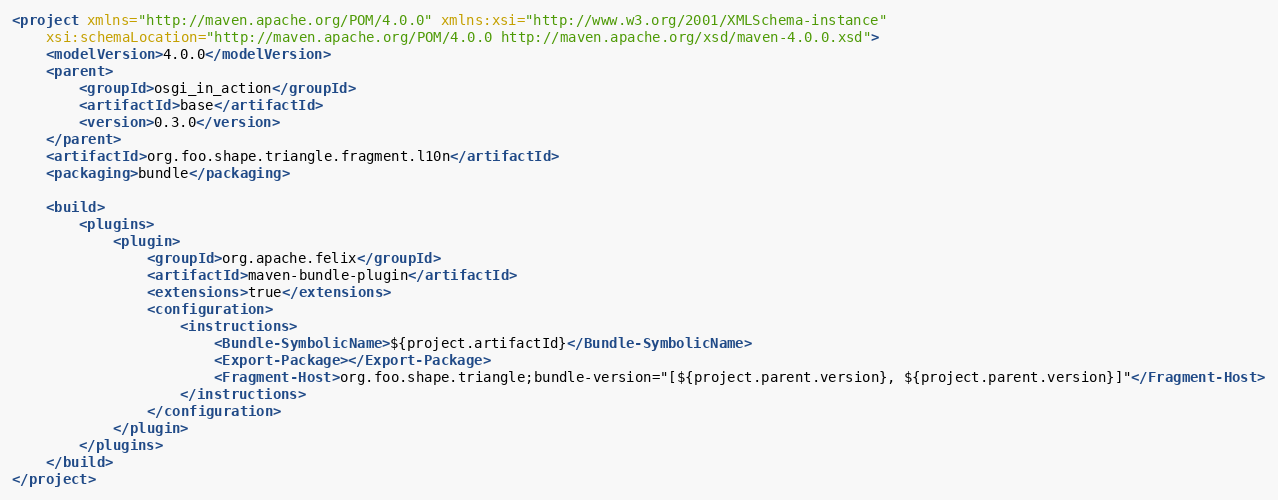Convert code to text. <code><loc_0><loc_0><loc_500><loc_500><_XML_><project xmlns="http://maven.apache.org/POM/4.0.0" xmlns:xsi="http://www.w3.org/2001/XMLSchema-instance"
	xsi:schemaLocation="http://maven.apache.org/POM/4.0.0 http://maven.apache.org/xsd/maven-4.0.0.xsd">
	<modelVersion>4.0.0</modelVersion>
	<parent>
		<groupId>osgi_in_action</groupId>
		<artifactId>base</artifactId>
		<version>0.3.0</version>
	</parent>
	<artifactId>org.foo.shape.triangle.fragment.l10n</artifactId>
	<packaging>bundle</packaging>
	
	<build>
		<plugins>
			<plugin>
				<groupId>org.apache.felix</groupId>
				<artifactId>maven-bundle-plugin</artifactId>
				<extensions>true</extensions>
				<configuration>
					<instructions>
						<Bundle-SymbolicName>${project.artifactId}</Bundle-SymbolicName>
						<Export-Package></Export-Package>
						<Fragment-Host>org.foo.shape.triangle;bundle-version="[${project.parent.version}, ${project.parent.version}]"</Fragment-Host>
					</instructions>
				</configuration>
			</plugin>
		</plugins>
	</build>
</project></code> 